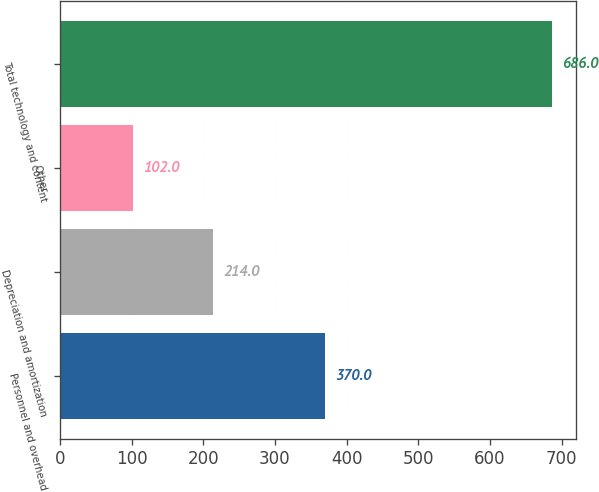Convert chart to OTSL. <chart><loc_0><loc_0><loc_500><loc_500><bar_chart><fcel>Personnel and overhead<fcel>Depreciation and amortization<fcel>Other<fcel>Total technology and content<nl><fcel>370<fcel>214<fcel>102<fcel>686<nl></chart> 